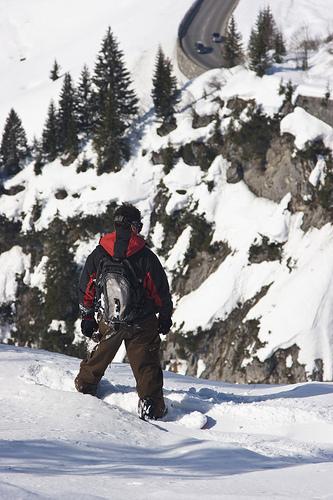What is on the ground?
Keep it brief. Snow. Is it summer?
Answer briefly. No. Does the ground look frozen?
Short answer required. Yes. 